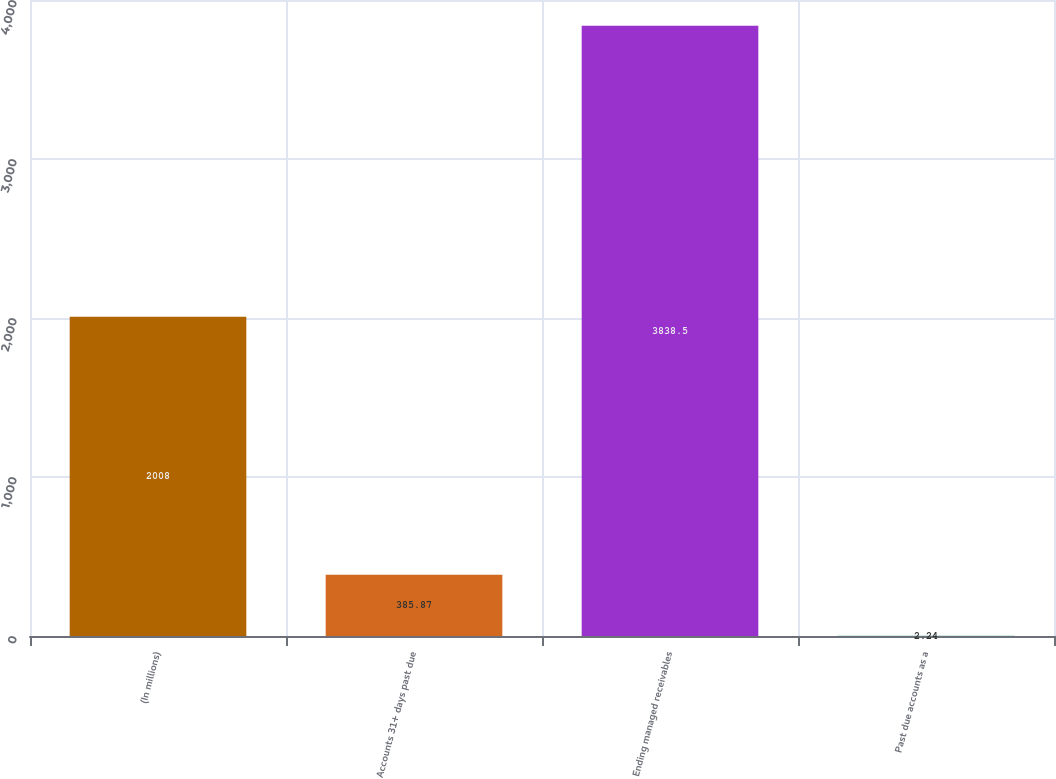Convert chart to OTSL. <chart><loc_0><loc_0><loc_500><loc_500><bar_chart><fcel>(In millions)<fcel>Accounts 31+ days past due<fcel>Ending managed receivables<fcel>Past due accounts as a<nl><fcel>2008<fcel>385.87<fcel>3838.5<fcel>2.24<nl></chart> 